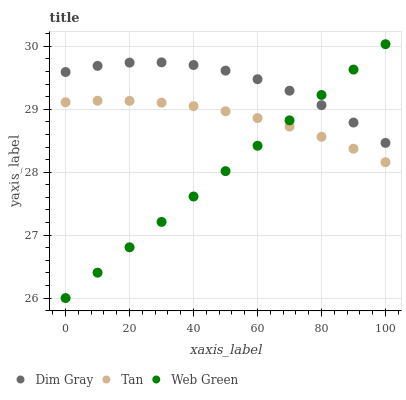Does Web Green have the minimum area under the curve?
Answer yes or no. Yes. Does Dim Gray have the maximum area under the curve?
Answer yes or no. Yes. Does Dim Gray have the minimum area under the curve?
Answer yes or no. No. Does Web Green have the maximum area under the curve?
Answer yes or no. No. Is Web Green the smoothest?
Answer yes or no. Yes. Is Dim Gray the roughest?
Answer yes or no. Yes. Is Dim Gray the smoothest?
Answer yes or no. No. Is Web Green the roughest?
Answer yes or no. No. Does Web Green have the lowest value?
Answer yes or no. Yes. Does Dim Gray have the lowest value?
Answer yes or no. No. Does Web Green have the highest value?
Answer yes or no. Yes. Does Dim Gray have the highest value?
Answer yes or no. No. Is Tan less than Dim Gray?
Answer yes or no. Yes. Is Dim Gray greater than Tan?
Answer yes or no. Yes. Does Tan intersect Web Green?
Answer yes or no. Yes. Is Tan less than Web Green?
Answer yes or no. No. Is Tan greater than Web Green?
Answer yes or no. No. Does Tan intersect Dim Gray?
Answer yes or no. No. 